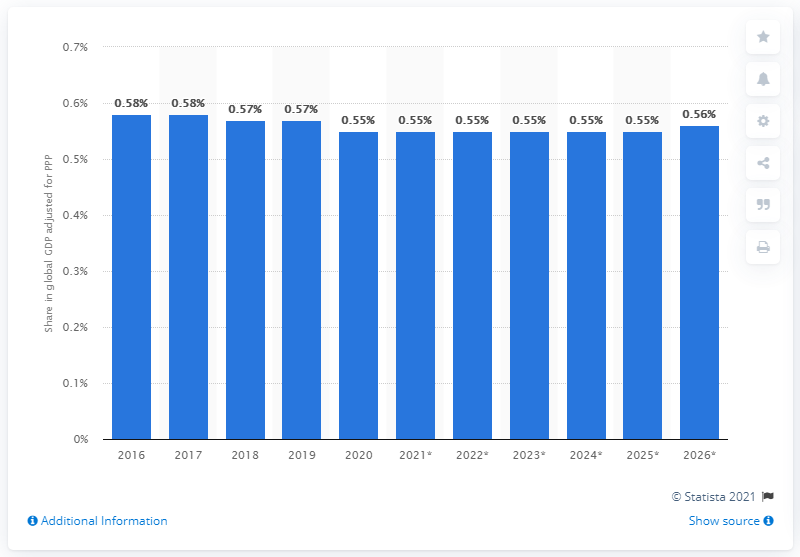Indicate a few pertinent items in this graphic. According to the Global Gross Domestic Product adjusted for Purchasing Power Parity in 2020, Colombia's share was estimated to be 0.55. 